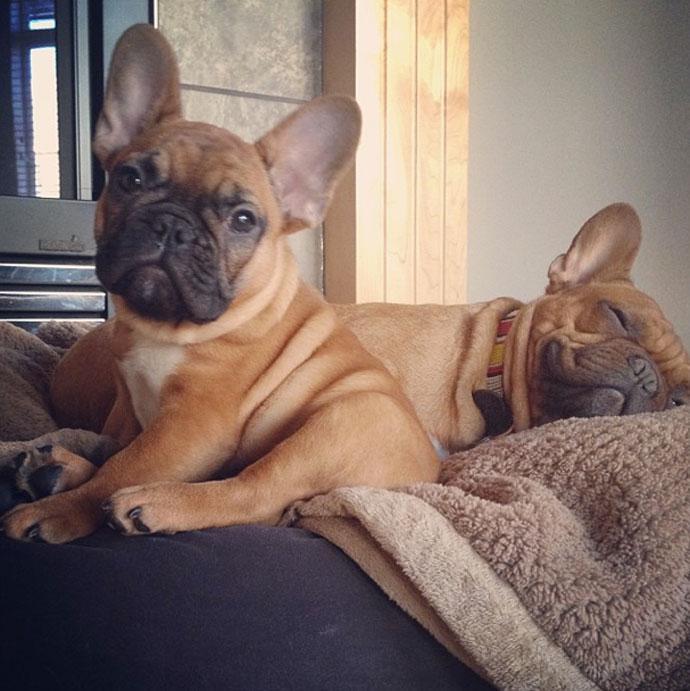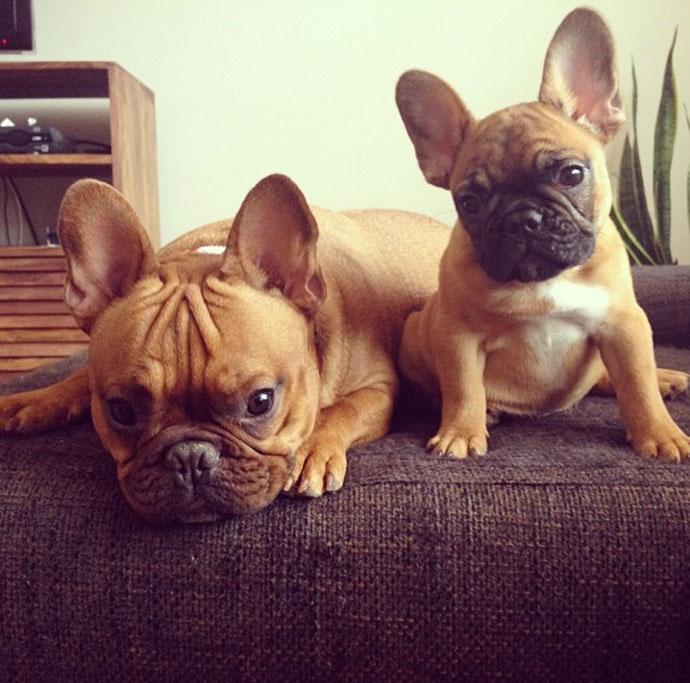The first image is the image on the left, the second image is the image on the right. Examine the images to the left and right. Is the description "Two dogs are standing up in the image on the left." accurate? Answer yes or no. No. The first image is the image on the left, the second image is the image on the right. For the images shown, is this caption "Each image contains a pair of big-eared dogs, and the pair on the left stand on all fours." true? Answer yes or no. No. The first image is the image on the left, the second image is the image on the right. Given the left and right images, does the statement "There are two dogs with mouths open and tongue visible in the left image." hold true? Answer yes or no. No. The first image is the image on the left, the second image is the image on the right. Assess this claim about the two images: "An image shows two tan big-eared dogs posed alongside each other on a seat cushion with a burlap-like rough woven texture.". Correct or not? Answer yes or no. Yes. 